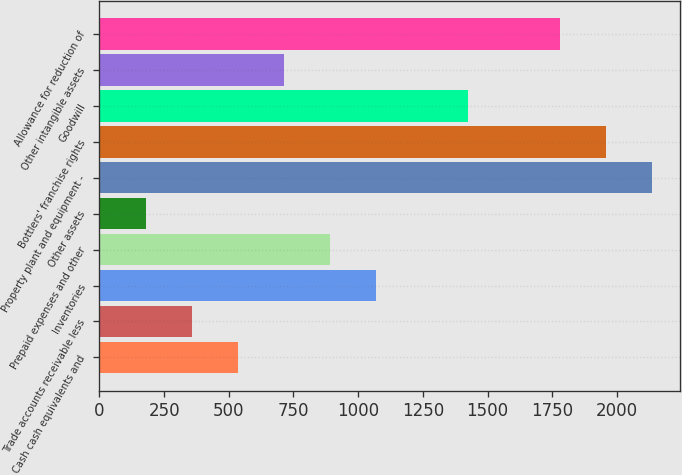Convert chart. <chart><loc_0><loc_0><loc_500><loc_500><bar_chart><fcel>Cash cash equivalents and<fcel>Trade accounts receivable less<fcel>Inventories<fcel>Prepaid expenses and other<fcel>Other assets<fcel>Property plant and equipment -<fcel>Bottlers' franchise rights<fcel>Goodwill<fcel>Other intangible assets<fcel>Allowance for reduction of<nl><fcel>534.7<fcel>356.8<fcel>1068.4<fcel>890.5<fcel>178.9<fcel>2135.8<fcel>1957.9<fcel>1424.2<fcel>712.6<fcel>1780<nl></chart> 